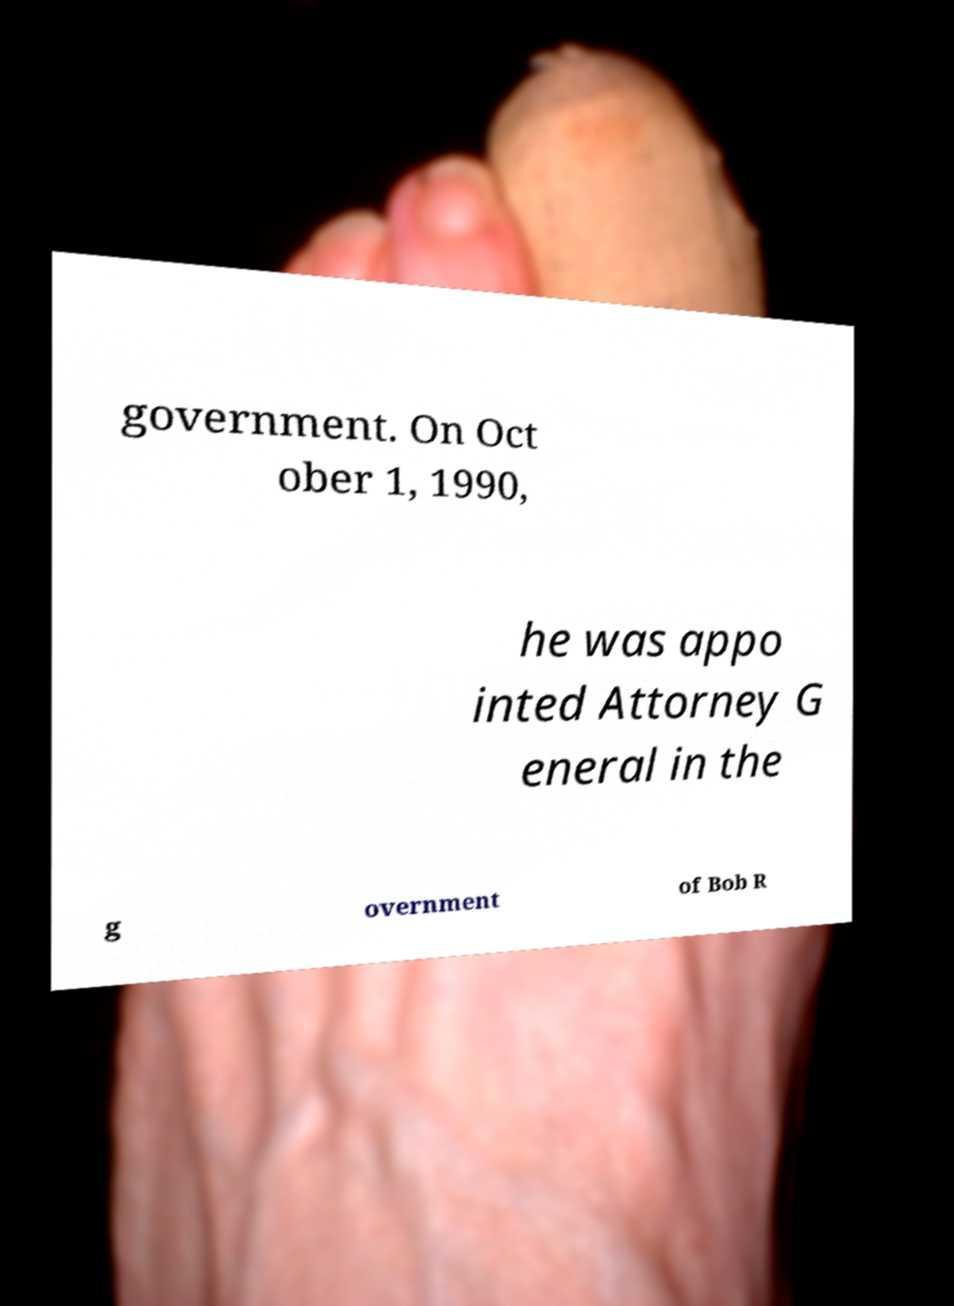For documentation purposes, I need the text within this image transcribed. Could you provide that? government. On Oct ober 1, 1990, he was appo inted Attorney G eneral in the g overnment of Bob R 